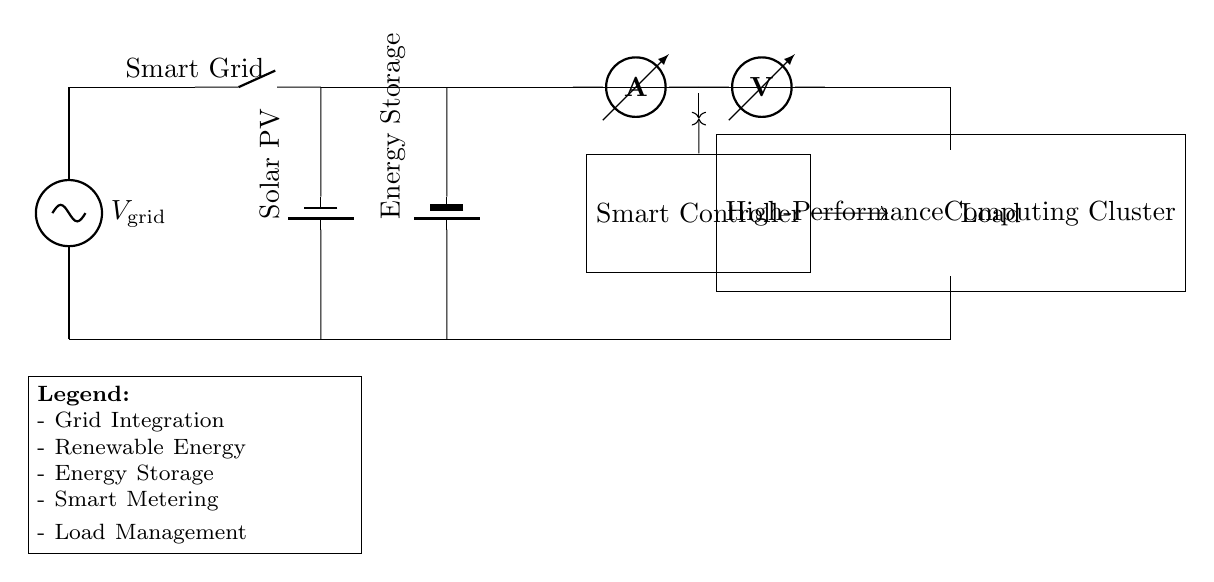What are the main energy sources in this circuit? The main energy sources in the circuit are the grid and solar photovoltaic (PV) panels. These sources are indicated at the top of the circuit diagram with labels showing the power sources.
Answer: Grid and solar PV What component measures current in the circuit? The ammeter measures the current flowing through the circuit. It is one of the components shown in the circuit diagram, specifically placed after the energy sources.
Answer: Ammeter How does the smart controller interact with the load? The smart controller sends a control signal to the computing load, indicating the flow of energy and managing its consumption based on conditions such as energy availability. This is seen from the arrowed connections pointing from the controller to the load.
Answer: Through control signals What is the purpose of the energy storage component in this circuit? The energy storage component, labeled as Energy Storage, allows for the retention of excess energy generated, especially from renewable sources like solar PV, to be used when necessary, thus balancing supply and demand.
Answer: Energy retention Calculate total voltage available in this circuit (assuming voltage from grid is 120 volts and solar PV is 60 volts) The total voltage of the circuit is the sum of the voltages from each energy source, which in this scenario is 120 volts from the grid plus 60 volts from the solar PV, resulting in a total of 180 volts.
Answer: 180 volts What type of high power appliance is represented in the circuit? The high-performance computing cluster is the appliance represented in this circuit. It is shown as a distinct block on the right side of the diagram labeled accordingly.
Answer: High-performance computing cluster What does the voltmeter measure in this integration circuit? The voltmeter measures the voltage across the high-performance computing cluster, providing insight into the energy usage and efficiency of the appliance. This is indicated in the diagram where the voltmeter is connected parallel to the load for measurement.
Answer: Voltage across the load 